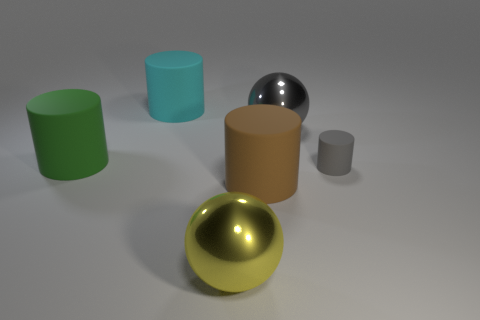There is a ball that is the same color as the small rubber object; what size is it?
Offer a very short reply. Large. Is there another gray metal thing that has the same shape as the large gray metallic object?
Your response must be concise. No. Is the size of the shiny object that is in front of the big green matte object the same as the metallic ball to the right of the yellow sphere?
Give a very brief answer. Yes. Is the number of big shiny spheres on the left side of the gray cylinder less than the number of cylinders behind the green thing?
Offer a terse response. No. There is a large sphere that is the same color as the tiny rubber object; what material is it?
Offer a very short reply. Metal. There is a big sphere that is left of the brown cylinder; what color is it?
Your answer should be compact. Yellow. What number of big rubber objects are to the right of the object that is left of the big cylinder that is behind the big gray metal object?
Make the answer very short. 2. The yellow metal sphere has what size?
Provide a short and direct response. Large. There is another sphere that is the same size as the gray metal sphere; what is it made of?
Offer a very short reply. Metal. What number of big brown things are right of the green cylinder?
Your answer should be compact. 1. 